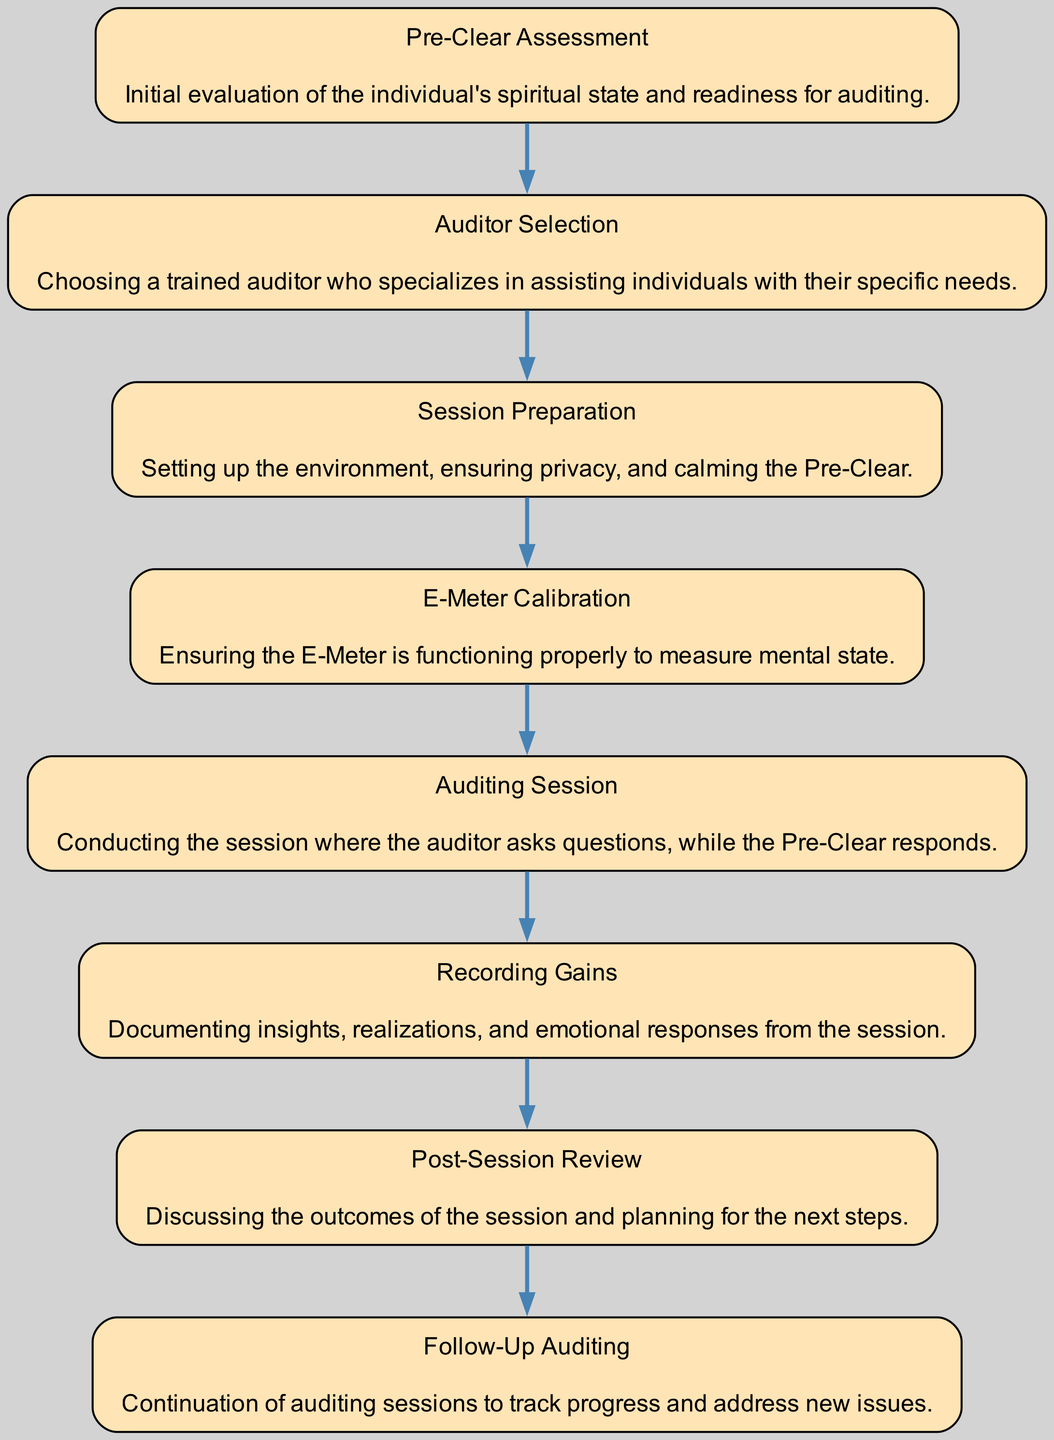What is the first step in the auditing process flow? The diagram starts with "Pre-Clear Assessment" as the first node, which indicates the initial evaluation of the individual's spiritual state and readiness for auditing.
Answer: Pre-Clear Assessment How many key steps are there in the auditing process? By counting the nodes in the diagram, there are a total of eight significant steps denoted, which are represented as elements in the process flow.
Answer: Eight What step follows "E-Meter Calibration"? According to the flow chart, after "E-Meter Calibration," the next step is "Auditing Session." This implies that the calibration is done before conducting the actual session.
Answer: Auditing Session What is documented during the process? The diagram specifically mentions "Recording Gains," which indicates that insights, realizations, and emotional responses from the session are documented.
Answer: Recording Gains Which step involves discussing outcomes of the session? The "Post-Session Review" is where the outcomes of the auditing session are discussed, allowing for planning for future sessions.
Answer: Post-Session Review How does the "Auditor Selection" step relate to "Session Preparation"? After the "Auditor Selection," the flow indicates that the selected auditor then moves on to "Session Preparation," showing a sequential relationship between choosing the auditor and preparing for the session.
Answer: Sequential relationship What is the purpose of the "Follow-Up Auditing" step? The purpose of "Follow-Up Auditing" is to continue auditing sessions to track progress and address new issues, showing an ongoing relationship in the auditing process.
Answer: Track progress How does the E-Meter fit into the auditing process? The "E-Meter Calibration" step is crucial as it ensures that the E-Meter is functioning correctly, which is essential for measuring the Pre-Clear's mental state during the "Auditing Session." Therefore, the E-Meter is a key tool used throughout this process.
Answer: Essential tool What action precedes recording insights in the auditing process? Before "Recording Gains," the action that occurs is the "Auditing Session," where the insights and emotional responses are gathered prior to documentation.
Answer: Auditing Session What is the primary aim of the "Pre-Clear Assessment"? The primary aim of "Pre-Clear Assessment" is to evaluate the individual's spiritual state and ensure they are prepared for the auditing process.
Answer: Evaluate spiritual state 